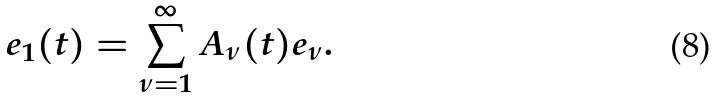<formula> <loc_0><loc_0><loc_500><loc_500>e _ { 1 } ( t ) = \sum _ { \nu = 1 } ^ { \infty } A _ { \nu } ( t ) e _ { \nu } .</formula> 